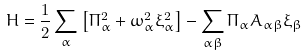Convert formula to latex. <formula><loc_0><loc_0><loc_500><loc_500>H = \frac { 1 } { 2 } \sum _ { \alpha } \left [ \Pi _ { \alpha } ^ { 2 } + \omega _ { \alpha } ^ { 2 } \xi _ { \alpha } ^ { 2 } \right ] - \sum _ { \alpha \beta } \Pi _ { \alpha } A _ { \alpha \beta } \xi _ { \beta }</formula> 